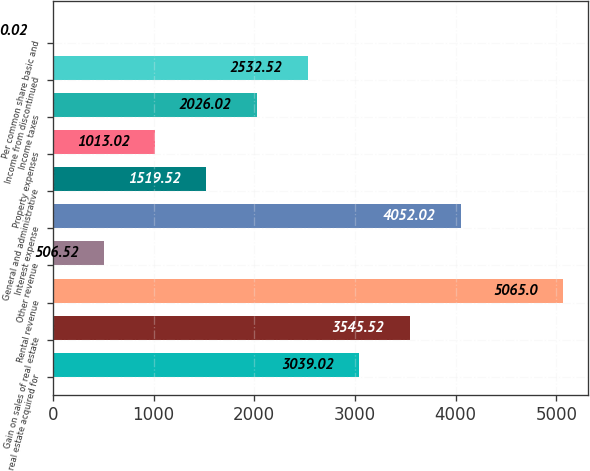Convert chart. <chart><loc_0><loc_0><loc_500><loc_500><bar_chart><fcel>real estate acquired for<fcel>Gain on sales of real estate<fcel>Rental revenue<fcel>Other revenue<fcel>Interest expense<fcel>General and administrative<fcel>Property expenses<fcel>Income taxes<fcel>Income from discontinued<fcel>Per common share basic and<nl><fcel>3039.02<fcel>3545.52<fcel>5065<fcel>506.52<fcel>4052.02<fcel>1519.52<fcel>1013.02<fcel>2026.02<fcel>2532.52<fcel>0.02<nl></chart> 